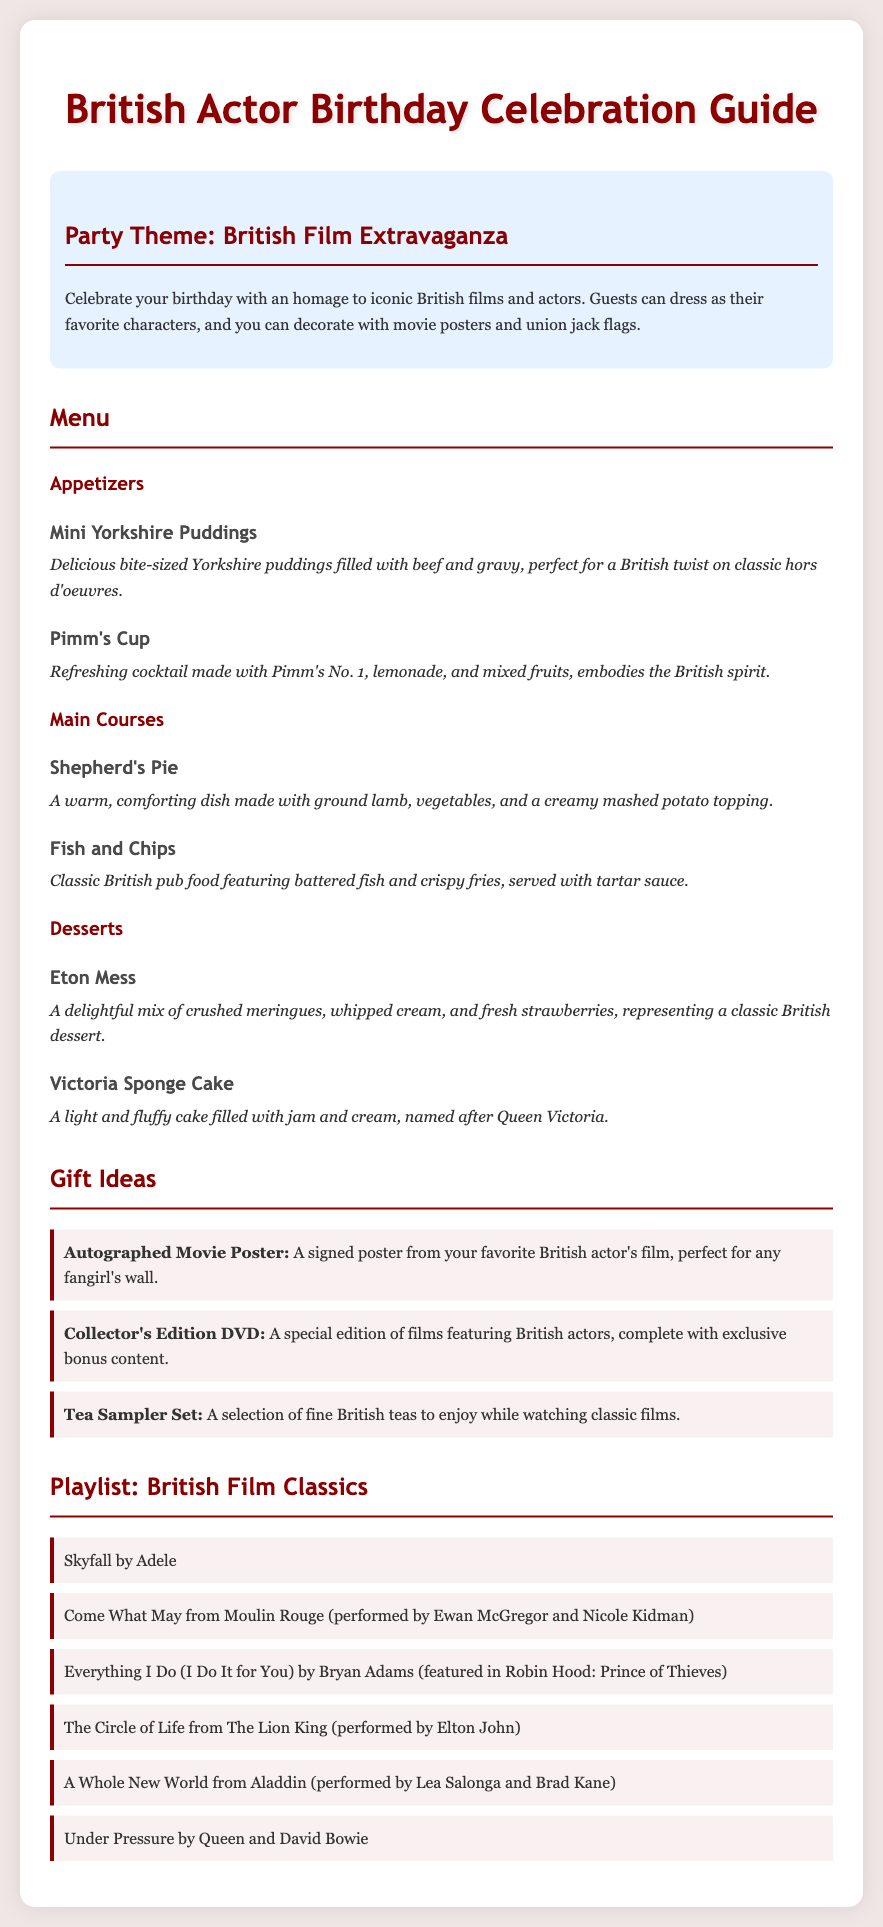What is the party theme? The party theme is specified as a British Film Extravaganza, celebrating iconic British films and actors.
Answer: British Film Extravaganza What are the appetizers listed? The appetizers listed are Mini Yorkshire Puddings and Pimm's Cup, which are detailed in the menu.
Answer: Mini Yorkshire Puddings, Pimm's Cup What is a suggested gift idea? One of the suggested gift ideas is an Autographed Movie Poster, which is a perfect gift for fans.
Answer: Autographed Movie Poster Which dessert includes strawberries? The dessert that includes strawberries is Eton Mess, as described in the menu section.
Answer: Eton Mess How many main courses are mentioned? There are two main courses mentioned in the menu: Shepherd's Pie and Fish and Chips.
Answer: 2 What is included in the playlist? The playlist includes "Skyfall" by Adele, among other classic British film songs.
Answer: Skyfall by Adele Who performed "Come What May"? The performance of "Come What May" is attributed to Ewan McGregor and Nicole Kidman in the document.
Answer: Ewan McGregor and Nicole Kidman What is a unique beverage mentioned in the appetizer section? The unique beverage mentioned in the appetizer section is Pimm's Cup, which embodies the British spirit.
Answer: Pimm's Cup 